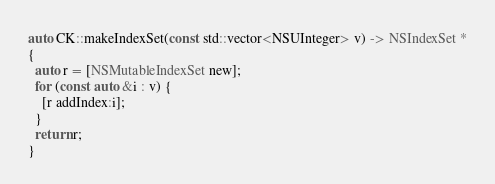Convert code to text. <code><loc_0><loc_0><loc_500><loc_500><_ObjectiveC_>
auto CK::makeIndexSet(const std::vector<NSUInteger> v) -> NSIndexSet *
{
  auto r = [NSMutableIndexSet new];
  for (const auto &i : v) {
    [r addIndex:i];
  }
  return r;
}
</code> 